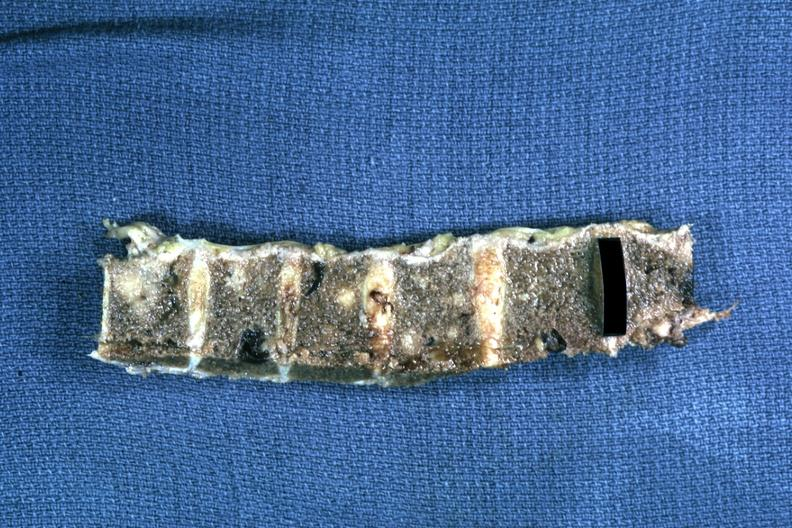what does this image show?
Answer the question using a single word or phrase. Fixed tissue obvious marrow metastatic type lesions but not typical for myeloma 